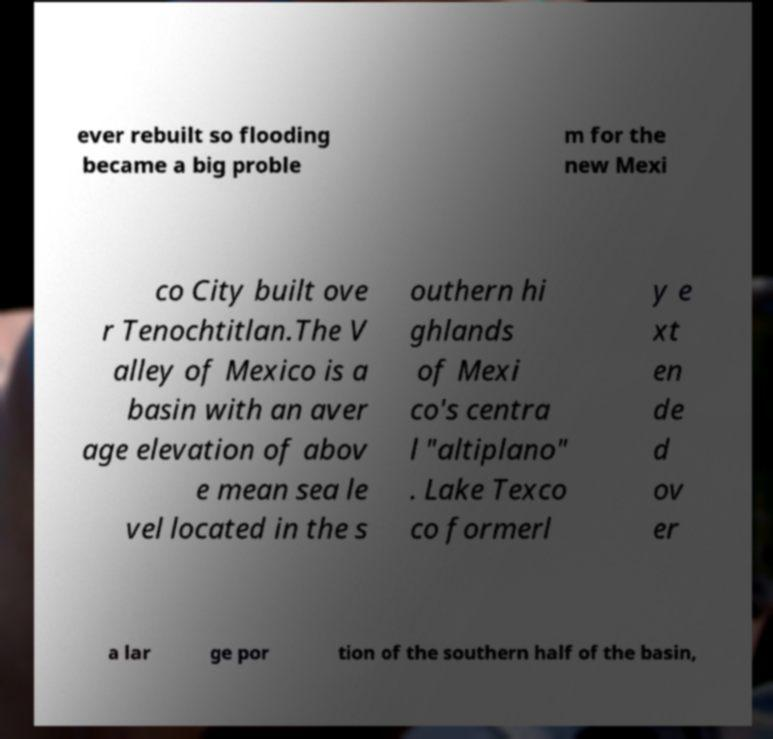Please read and relay the text visible in this image. What does it say? ever rebuilt so flooding became a big proble m for the new Mexi co City built ove r Tenochtitlan.The V alley of Mexico is a basin with an aver age elevation of abov e mean sea le vel located in the s outhern hi ghlands of Mexi co's centra l "altiplano" . Lake Texco co formerl y e xt en de d ov er a lar ge por tion of the southern half of the basin, 